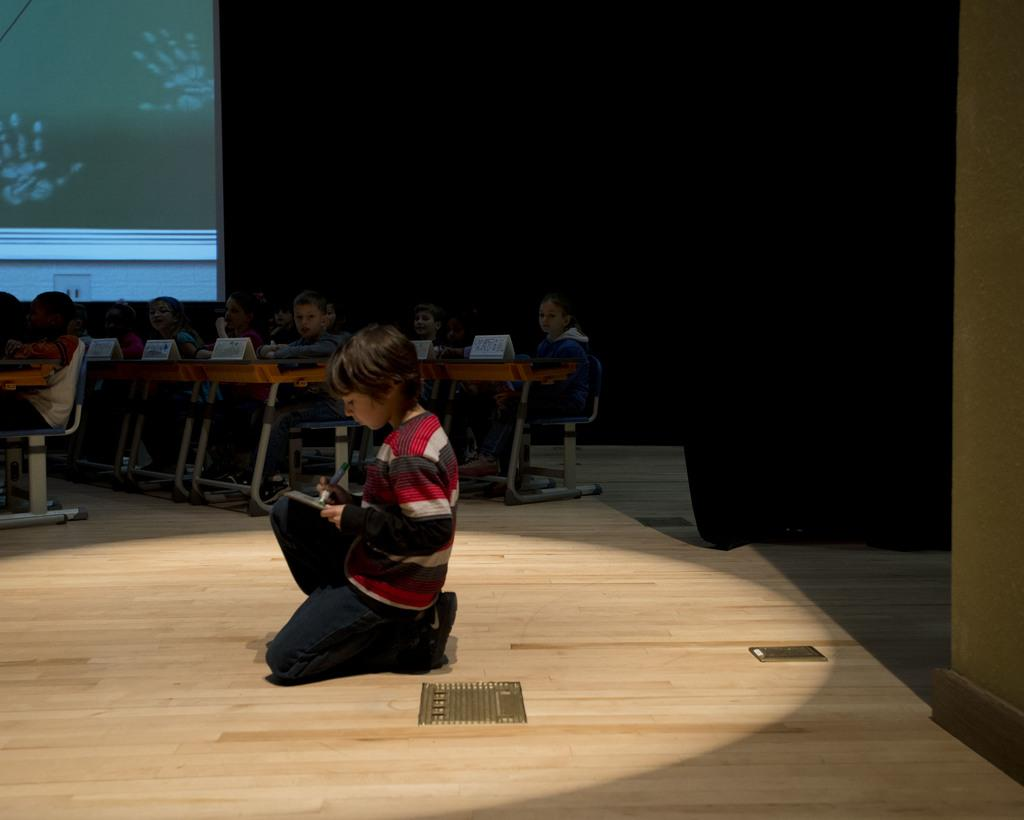Who is present in the image? There are children in the image. What are the children doing in the image? The children are sitting on chairs. What can be seen behind the children in the image? There is a wall visible in the background of the image, along with other objects. What type of wax is being used by the children in the image? There is no wax present in the image; the children are sitting on chairs. 